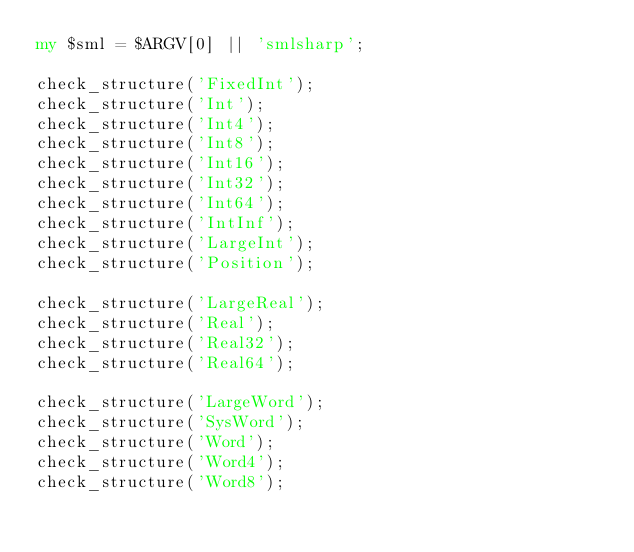Convert code to text. <code><loc_0><loc_0><loc_500><loc_500><_Perl_>my $sml = $ARGV[0] || 'smlsharp';

check_structure('FixedInt');
check_structure('Int');
check_structure('Int4');
check_structure('Int8');
check_structure('Int16');
check_structure('Int32');
check_structure('Int64');
check_structure('IntInf');
check_structure('LargeInt');
check_structure('Position');

check_structure('LargeReal');
check_structure('Real');
check_structure('Real32');
check_structure('Real64');

check_structure('LargeWord');
check_structure('SysWord');
check_structure('Word');
check_structure('Word4');
check_structure('Word8');</code> 